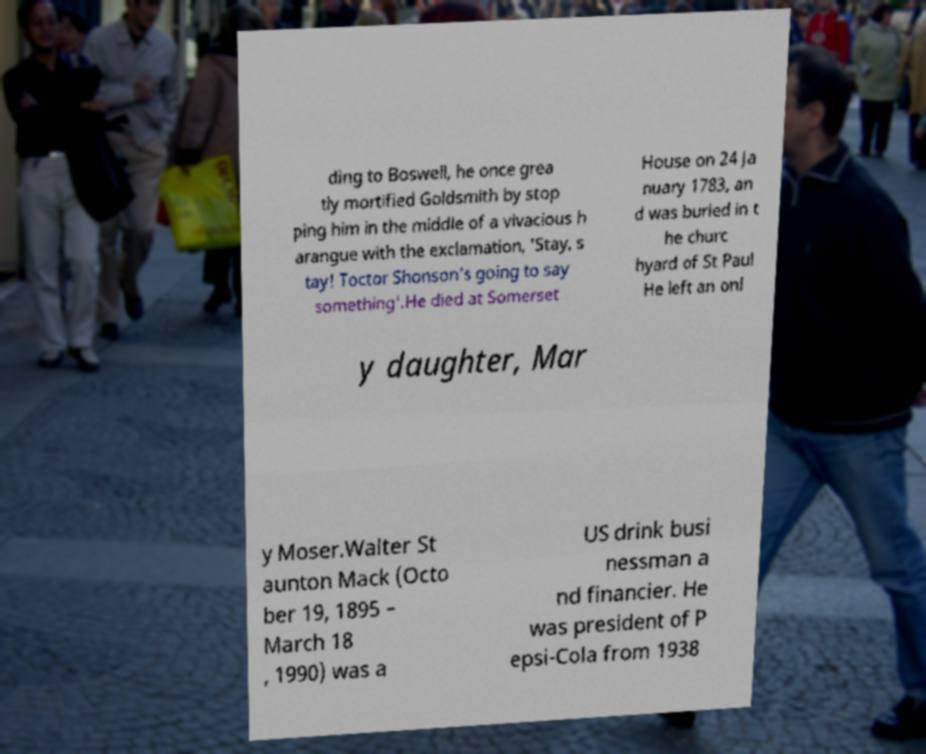Could you assist in decoding the text presented in this image and type it out clearly? ding to Boswell, he once grea tly mortified Goldsmith by stop ping him in the middle of a vivacious h arangue with the exclamation, 'Stay, s tay! Toctor Shonson's going to say something'.He died at Somerset House on 24 Ja nuary 1783, an d was buried in t he churc hyard of St Paul He left an onl y daughter, Mar y Moser.Walter St aunton Mack (Octo ber 19, 1895 – March 18 , 1990) was a US drink busi nessman a nd financier. He was president of P epsi-Cola from 1938 